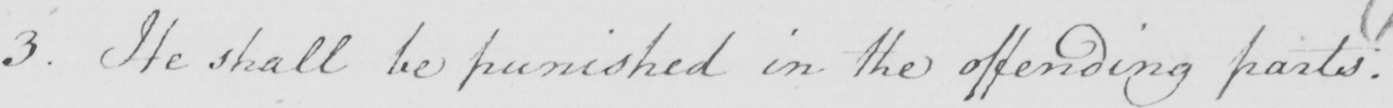What does this handwritten line say? 3 . He shall be punished in the offending parts . 